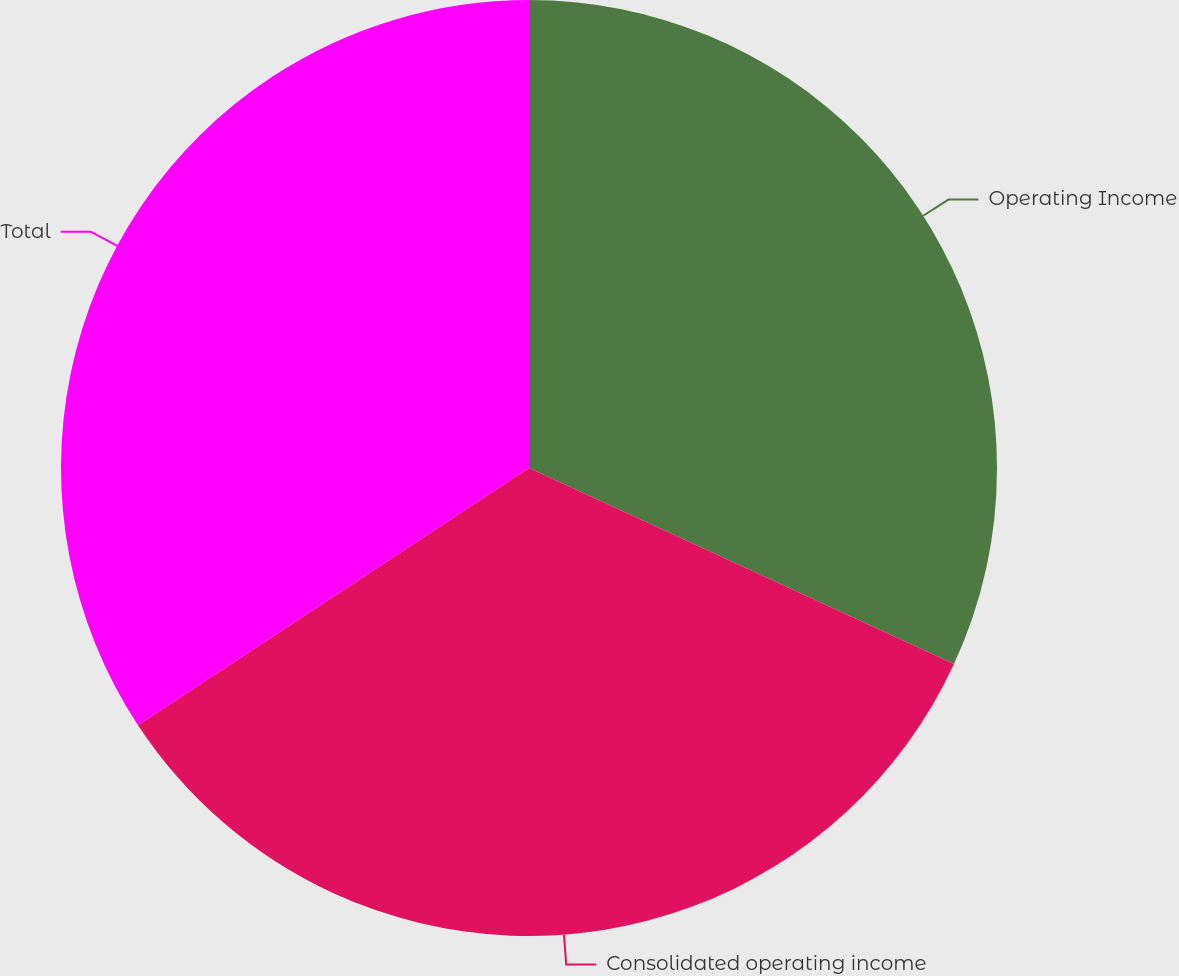Convert chart. <chart><loc_0><loc_0><loc_500><loc_500><pie_chart><fcel>Operating Income<fcel>Consolidated operating income<fcel>Total<nl><fcel>31.88%<fcel>33.86%<fcel>34.26%<nl></chart> 